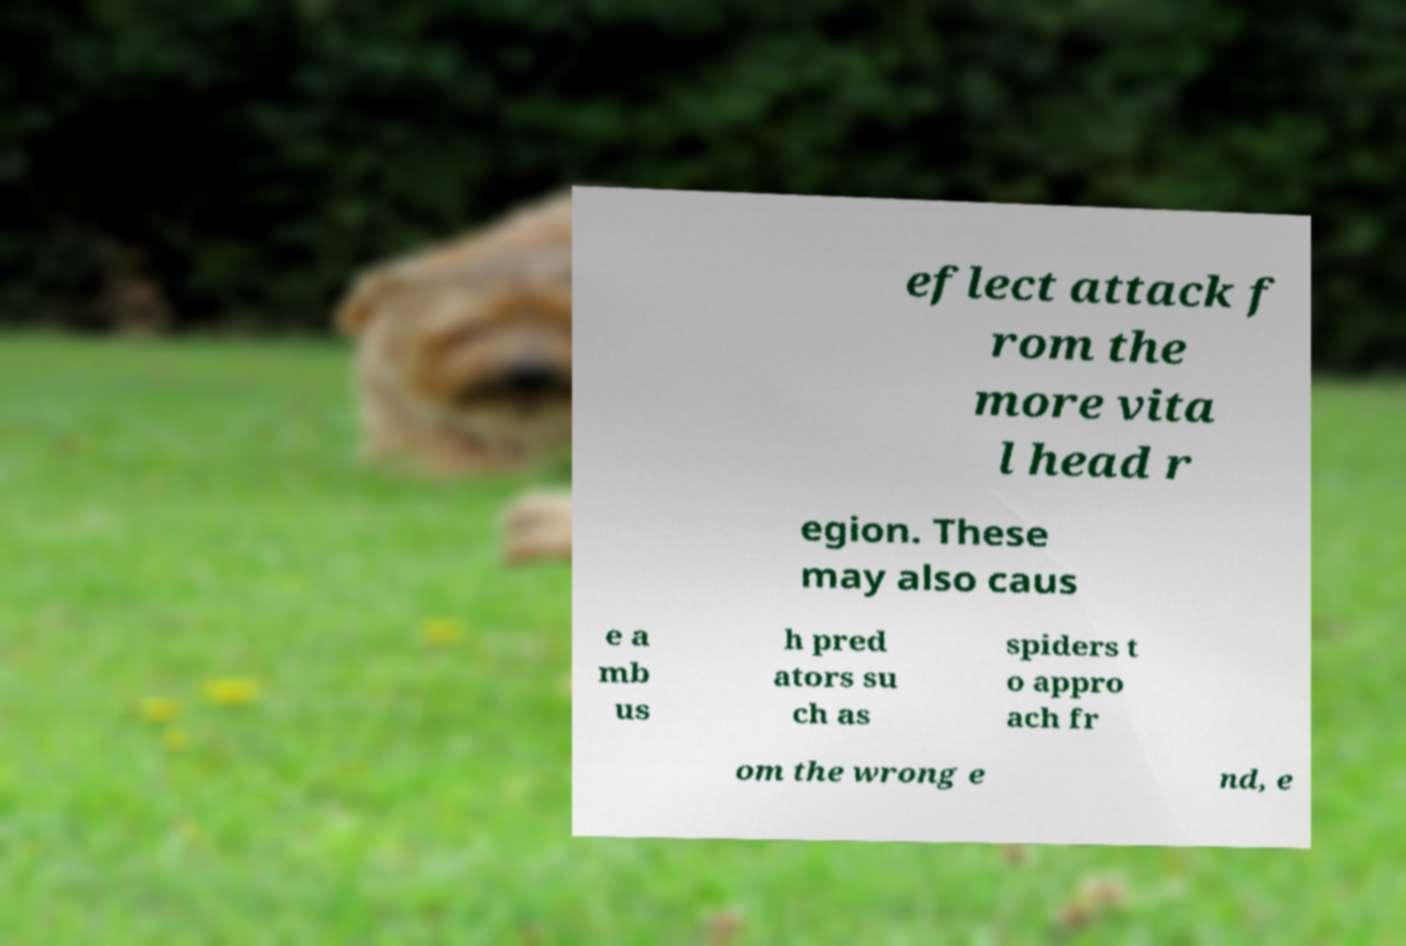Could you assist in decoding the text presented in this image and type it out clearly? eflect attack f rom the more vita l head r egion. These may also caus e a mb us h pred ators su ch as spiders t o appro ach fr om the wrong e nd, e 